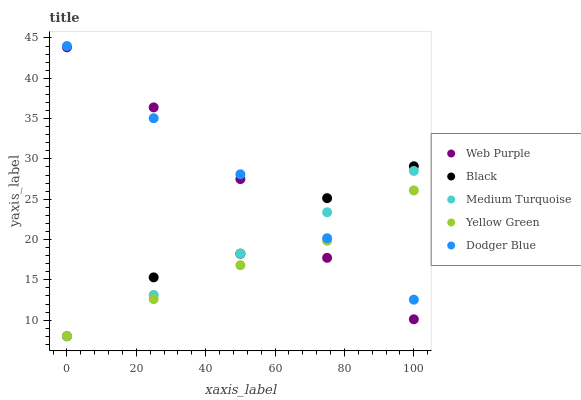Does Yellow Green have the minimum area under the curve?
Answer yes or no. Yes. Does Dodger Blue have the maximum area under the curve?
Answer yes or no. Yes. Does Web Purple have the minimum area under the curve?
Answer yes or no. No. Does Web Purple have the maximum area under the curve?
Answer yes or no. No. Is Medium Turquoise the smoothest?
Answer yes or no. Yes. Is Black the roughest?
Answer yes or no. Yes. Is Web Purple the smoothest?
Answer yes or no. No. Is Web Purple the roughest?
Answer yes or no. No. Does Black have the lowest value?
Answer yes or no. Yes. Does Web Purple have the lowest value?
Answer yes or no. No. Does Dodger Blue have the highest value?
Answer yes or no. Yes. Does Web Purple have the highest value?
Answer yes or no. No. Does Medium Turquoise intersect Dodger Blue?
Answer yes or no. Yes. Is Medium Turquoise less than Dodger Blue?
Answer yes or no. No. Is Medium Turquoise greater than Dodger Blue?
Answer yes or no. No. 